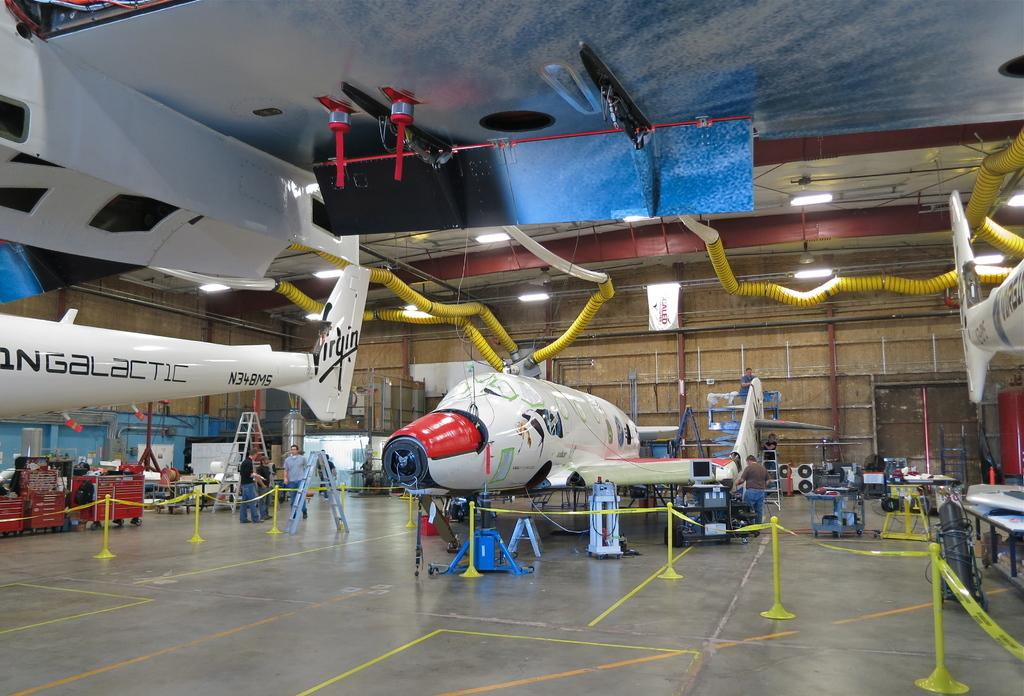<image>
Present a compact description of the photo's key features. an airplane hangar with jets from Virgin Galactic inside 